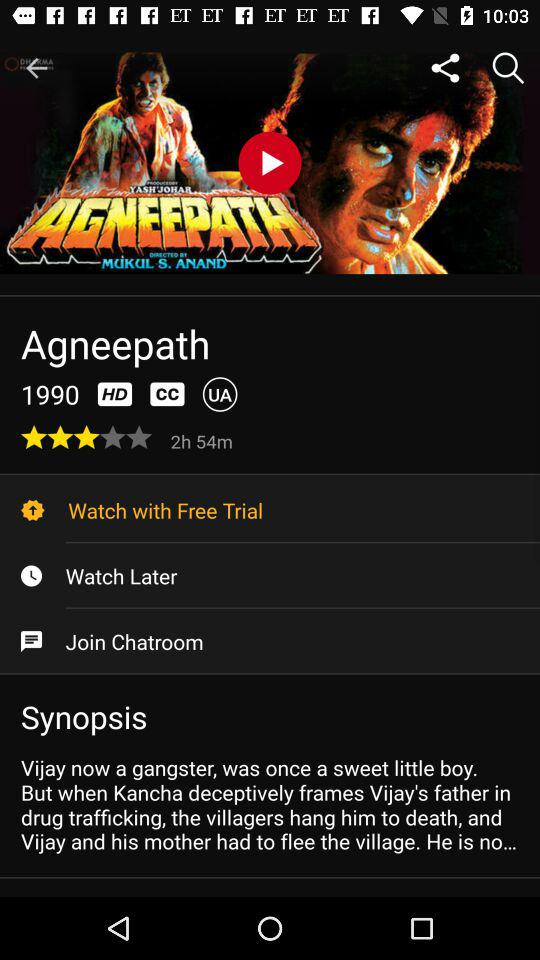How long is the movie?
Answer the question using a single word or phrase. 2h 54m 